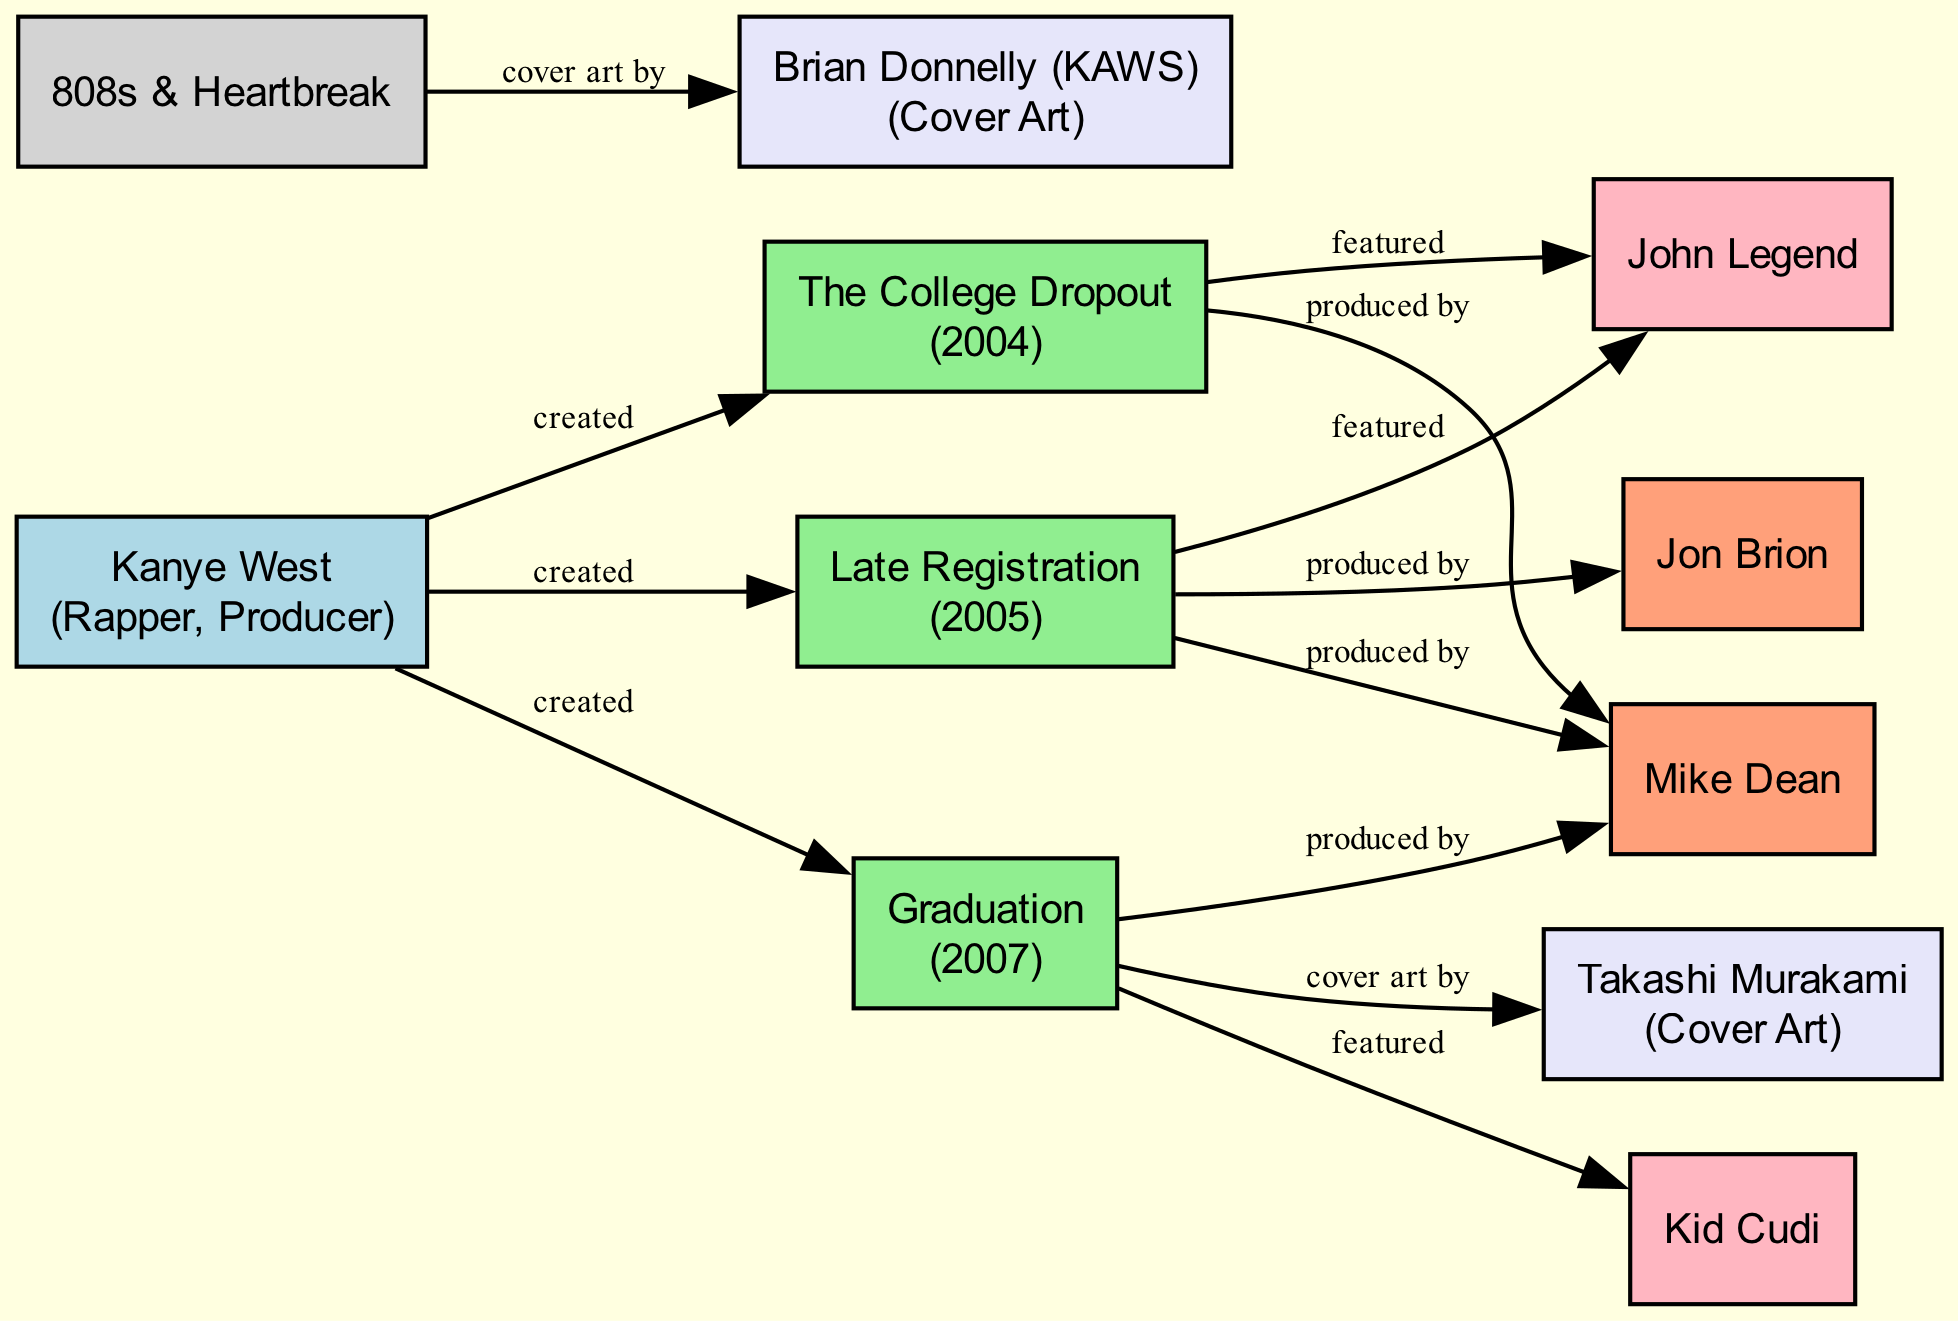What is the total number of albums created by Kanye West? There are three albums listed under Kanye West's creations: "The College Dropout," "Late Registration," and "Graduation." Counting these gives a total of three albums.
Answer: 3 Who was featured on "The College Dropout"? The connection from "The College Dropout" to "John Legend" shows that John Legend was featured on this album. Thus, he is the featured artist.
Answer: John Legend Which producer collaborated on all three albums: "The College Dropout," "Late Registration," and "Graduation"? The diagram indicates that "Mike Dean" is connected to all three albums as a producer. Thus, he is the producer who collaborated on all three albums.
Answer: Mike Dean How many visual artists collaborated with Kanye West on albums in the diagram? The diagram shows two visual artists: "Takashi Murakami" (on "Graduation") and "Brian Donnelly (KAWS)" (on "808s & Heartbreak"). Counting these indicates there are two visual artists who collaborated.
Answer: 2 What is the main role of Takashi Murakami in Kanye West's work? Takashi Murakami is connected to the "Graduation" album specifically noted for his role as cover art. This indicates that his main role is related to visual presentation.
Answer: Cover Art Which album features Kid Cudi as a collaborator? The connection from "Graduation" to "Kid Cudi" indicates that Kid Cudi is featured on this particular album. Therefore, "Graduation" is the album in which he collaborates.
Answer: Graduation Who produced "Late Registration"? The diagram lists "Jon Brion" as producing "Late Registration," along with "Mike Dean." This means Jon Brion is one of the producers for that album.
Answer: Jon Brion How many collaborations are listed for Mike Dean? The diagram shows connections for Mike Dean to "The College Dropout," "Late Registration," and "Graduation," indicating three collaboration instances.
Answer: 3 Which album has cover art by KAWS? The connection from "808s & Heartbreak" to "Brian Donnelly (KAWS)" shows that KAWS provided the cover art for this album, identifying it as the one with his work.
Answer: 808s & Heartbreak 